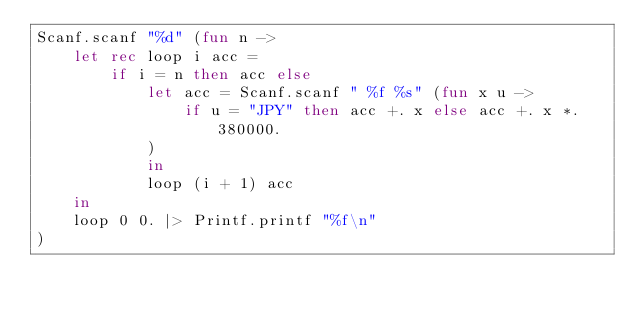Convert code to text. <code><loc_0><loc_0><loc_500><loc_500><_OCaml_>Scanf.scanf "%d" (fun n ->
    let rec loop i acc =
        if i = n then acc else
            let acc = Scanf.scanf " %f %s" (fun x u ->
                if u = "JPY" then acc +. x else acc +. x *. 380000.
            )
            in
            loop (i + 1) acc
    in
    loop 0 0. |> Printf.printf "%f\n"
)</code> 